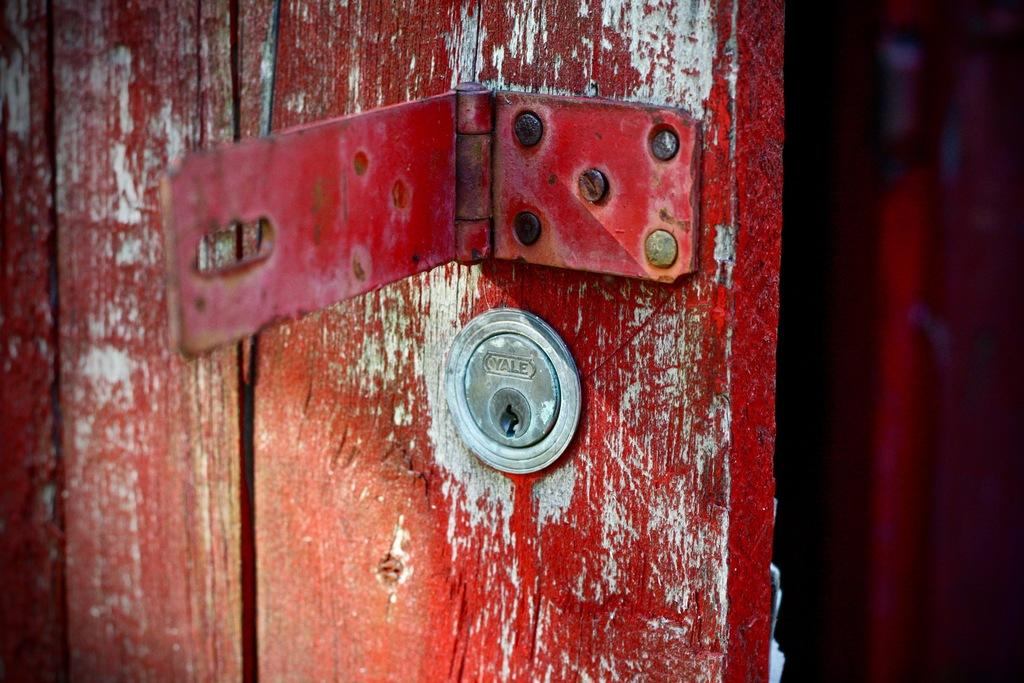What type of door is shown in the image? There is a wooden door in the image. What colors are used to paint the door? The door has red and white painting. Are there any security features on the door? Yes, there are locks on the door. What type of hardware can be seen on the door? There are screws on the door. Can you tell me how many boats are docked at the harbor in the image? There is no harbor or boats present in the image; it features a wooden door with red and white painting, locks, and screws. 